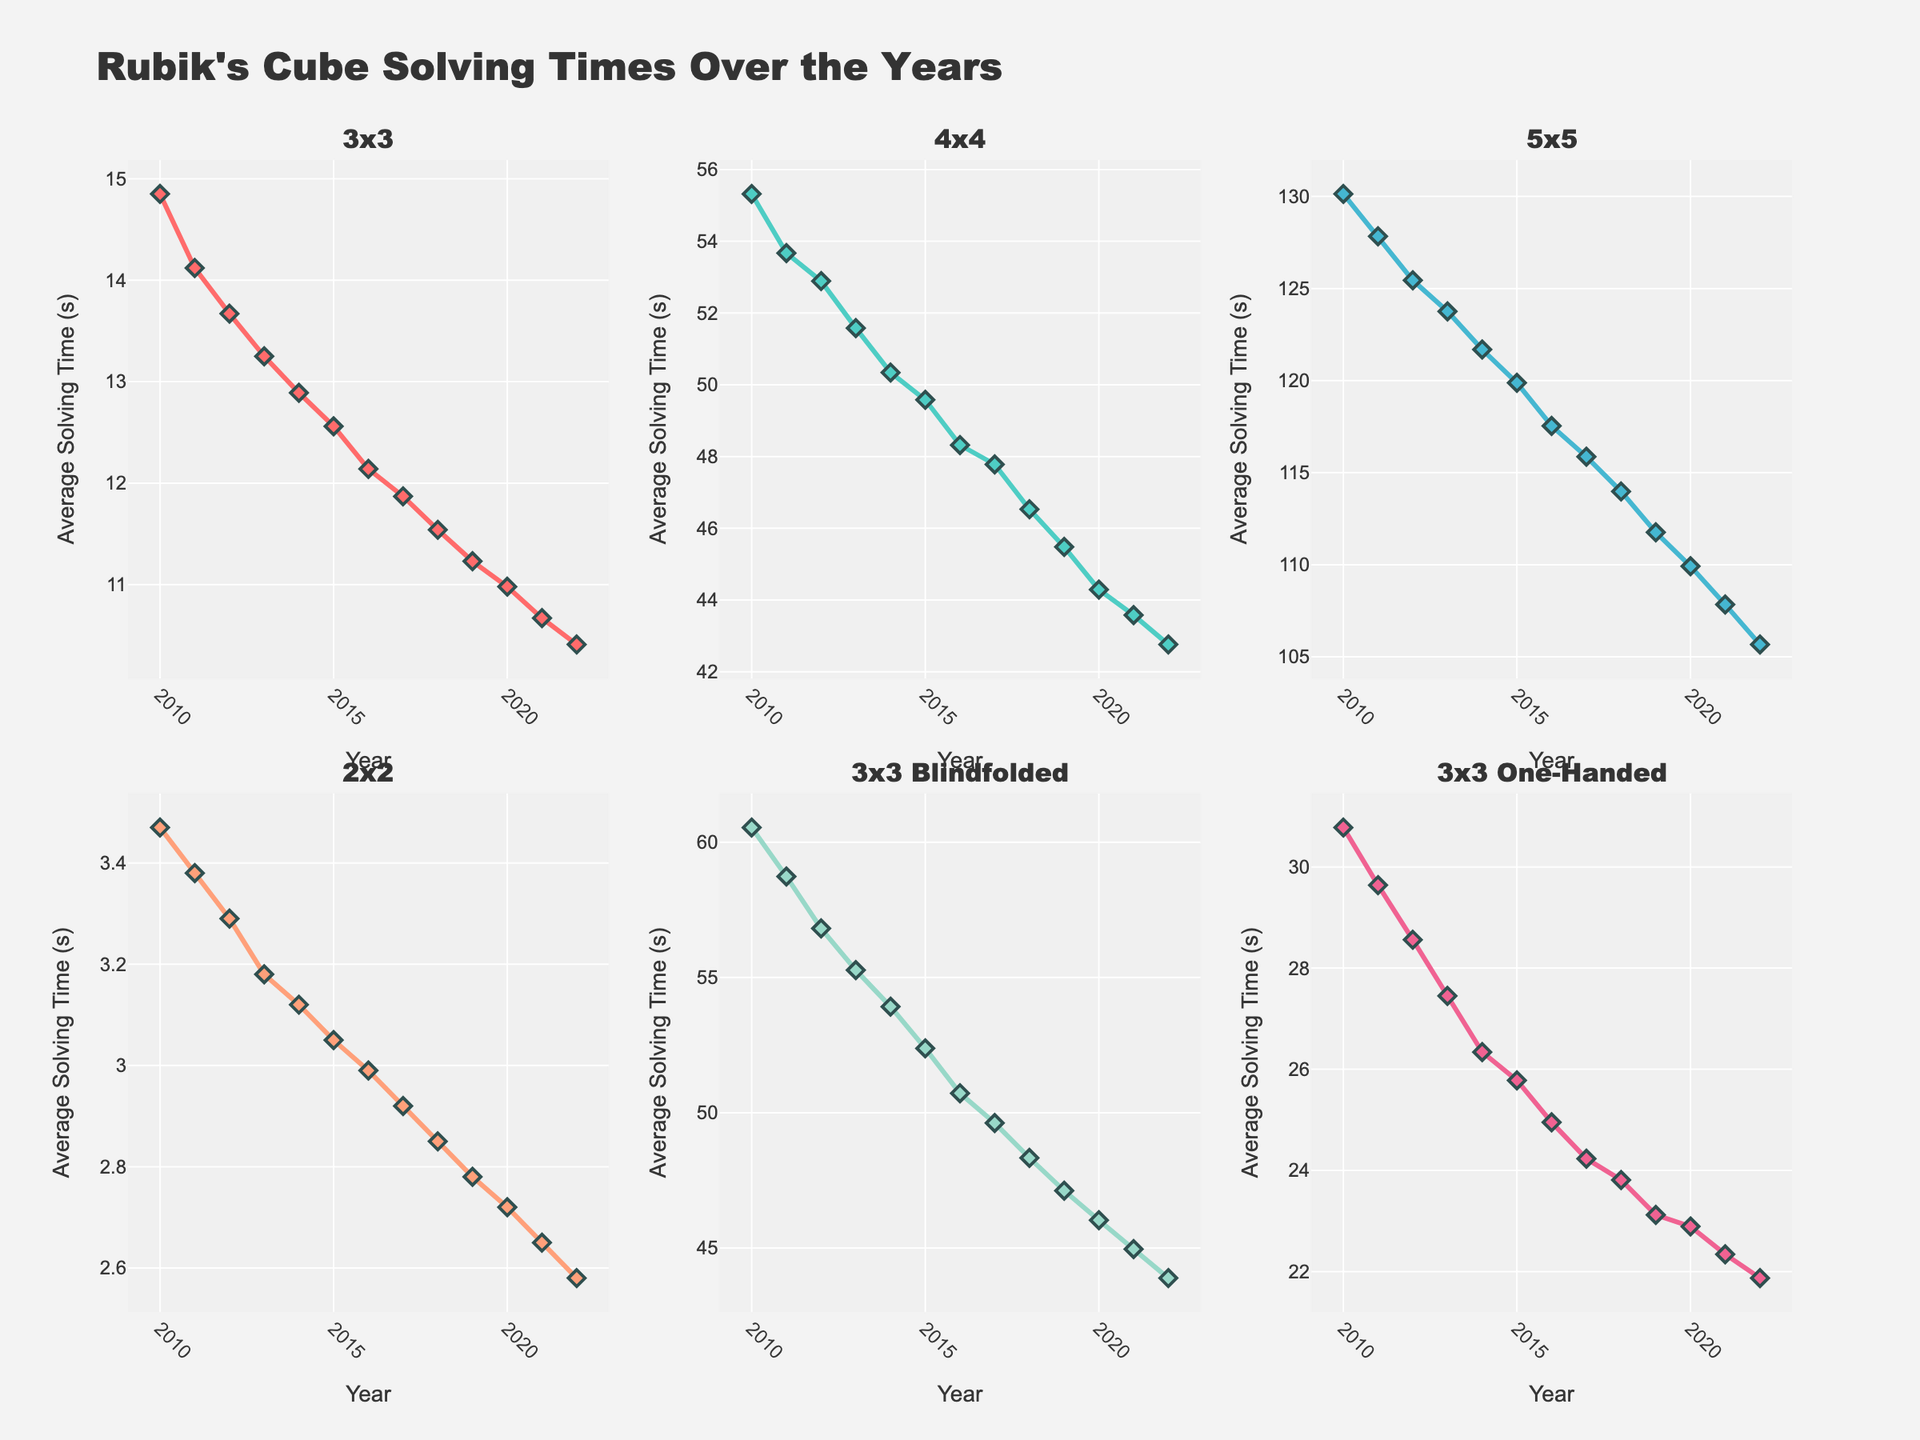How does the average solving time for 3x3 compare between 2010 and 2022? From the plot, find the data points for the 3x3 event in the years 2010 and 2022. The solving time in 2010 is 14.85 seconds, and in 2022 it is 10.41 seconds. Subtract the two to see the difference.
Answer: The average solving time for 3x3 has decreased by 4.44 seconds Which event showed the greatest improvement in solving time between 2010 and 2022? To determine the greatest improvement, compare the solving times of all events between 2010 and 2022. Calculate the difference for each event. The event with the largest positive difference has the greatest improvement.
Answer: The 3x3 One-Handed event showed the greatest improvement What is the trend in average solving times for the 2x2 event from 2010 to 2022? Look at the subplot specific to the 2x2 event and observe the trend of the data points from 2010 to 2022. Note whether the trend is increasing, decreasing, or stable.
Answer: The average solving time for the 2x2 event is decreasing By how much did the average solving time for 4x4 cubes change from 2010 to 2016? Find the average solving times for the 4x4 event in the years 2010 (55.32 seconds) and 2016 (48.32 seconds). Calculate the difference by subtracting the 2016 value from the 2010 value.
Answer: The average solving time for 4x4 cubes decreased by 7 seconds Which year saw the largest decrease in average solving time for the 3x3 Blindfolded event? Look at the 3x3 Blindfolded event subplot and identify the year-to-year differences in solving times. The year with the largest decrease will have the greatest downward change from the previous year.
Answer: 2021 saw the largest decrease How does the trend in average solving times for 3x3 One-Handed compare to that for 5x5? Compare the subplots for 3x3 One-Handed and 5x5. Observe and describe the overall trends in each event from 2010 to 2022. Note any similarities or differences.
Answer: Both trends show a decrease over time, but the 3x3 One-Handed has a steeper decline What was the average solving time for 5x5 in 2013, and how did it change by 2020? Locate the data points for the 5x5 event in 2013 (123.76 seconds) and in 2020 (109.92 seconds). Compute the difference to see how much it changed.
Answer: The average solving time for 5x5 decreased by 13.84 seconds Which event had the most consistent improvement in solving times over the years? To identify the most consistent improvement, evaluate each event’s subplot for steadiness in the downward trend. The event with the least variability while consistently decreasing has the most consistent improvement.
Answer: The 3x3 event had the most consistent improvement 